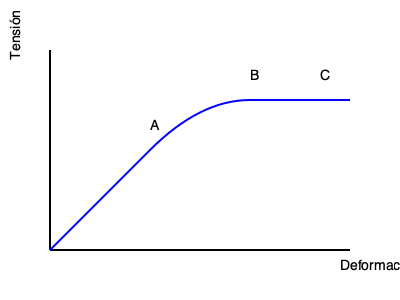En la curva de tensión-deformación mostrada, ¿qué representa el punto B en términos de las propiedades del material? Para interpretar la curva de tensión-deformación y determinar lo que representa el punto B, sigamos estos pasos:

1. Identifiquemos las partes principales de la curva:
   - La parte inicial lineal (desde el origen hasta el punto A) representa la región elástica.
   - El punto A es el límite elástico o punto de fluencia.
   - La región entre A y B es la zona de deformación plástica.
   - El punto B es el punto más alto de la curva.
   - La región después de B muestra una disminución en la tensión.

2. El punto B, siendo el punto más alto de la curva, representa el punto donde el material alcanza su máxima capacidad para soportar carga.

3. En ingeniería estructural, este punto se conoce como la resistencia última a la tracción o esfuerzo último.

4. La resistencia última a la tracción es la máxima tensión que un material puede soportar antes de que comience a fallar.

5. Después del punto B, el material comienza a experimentar una reducción en su capacidad para soportar carga, lo que eventualmente lleva a la fractura (punto C).

Por lo tanto, el punto B representa la resistencia última a la tracción del material, que es una propiedad crucial en el diseño de estructuras sostenibles, ya que permite determinar los límites de carga seguros para los materiales utilizados.
Answer: Resistencia última a la tracción 